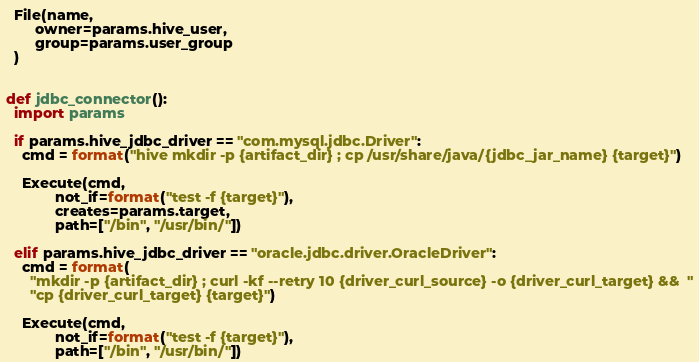<code> <loc_0><loc_0><loc_500><loc_500><_Python_>  File(name,
       owner=params.hive_user,
       group=params.user_group
  )


def jdbc_connector():
  import params

  if params.hive_jdbc_driver == "com.mysql.jdbc.Driver":
    cmd = format("hive mkdir -p {artifact_dir} ; cp /usr/share/java/{jdbc_jar_name} {target}")

    Execute(cmd,
            not_if=format("test -f {target}"),
            creates=params.target,
            path=["/bin", "/usr/bin/"])

  elif params.hive_jdbc_driver == "oracle.jdbc.driver.OracleDriver":
    cmd = format(
      "mkdir -p {artifact_dir} ; curl -kf --retry 10 {driver_curl_source} -o {driver_curl_target} &&  "
      "cp {driver_curl_target} {target}")

    Execute(cmd,
            not_if=format("test -f {target}"),
            path=["/bin", "/usr/bin/"])
</code> 